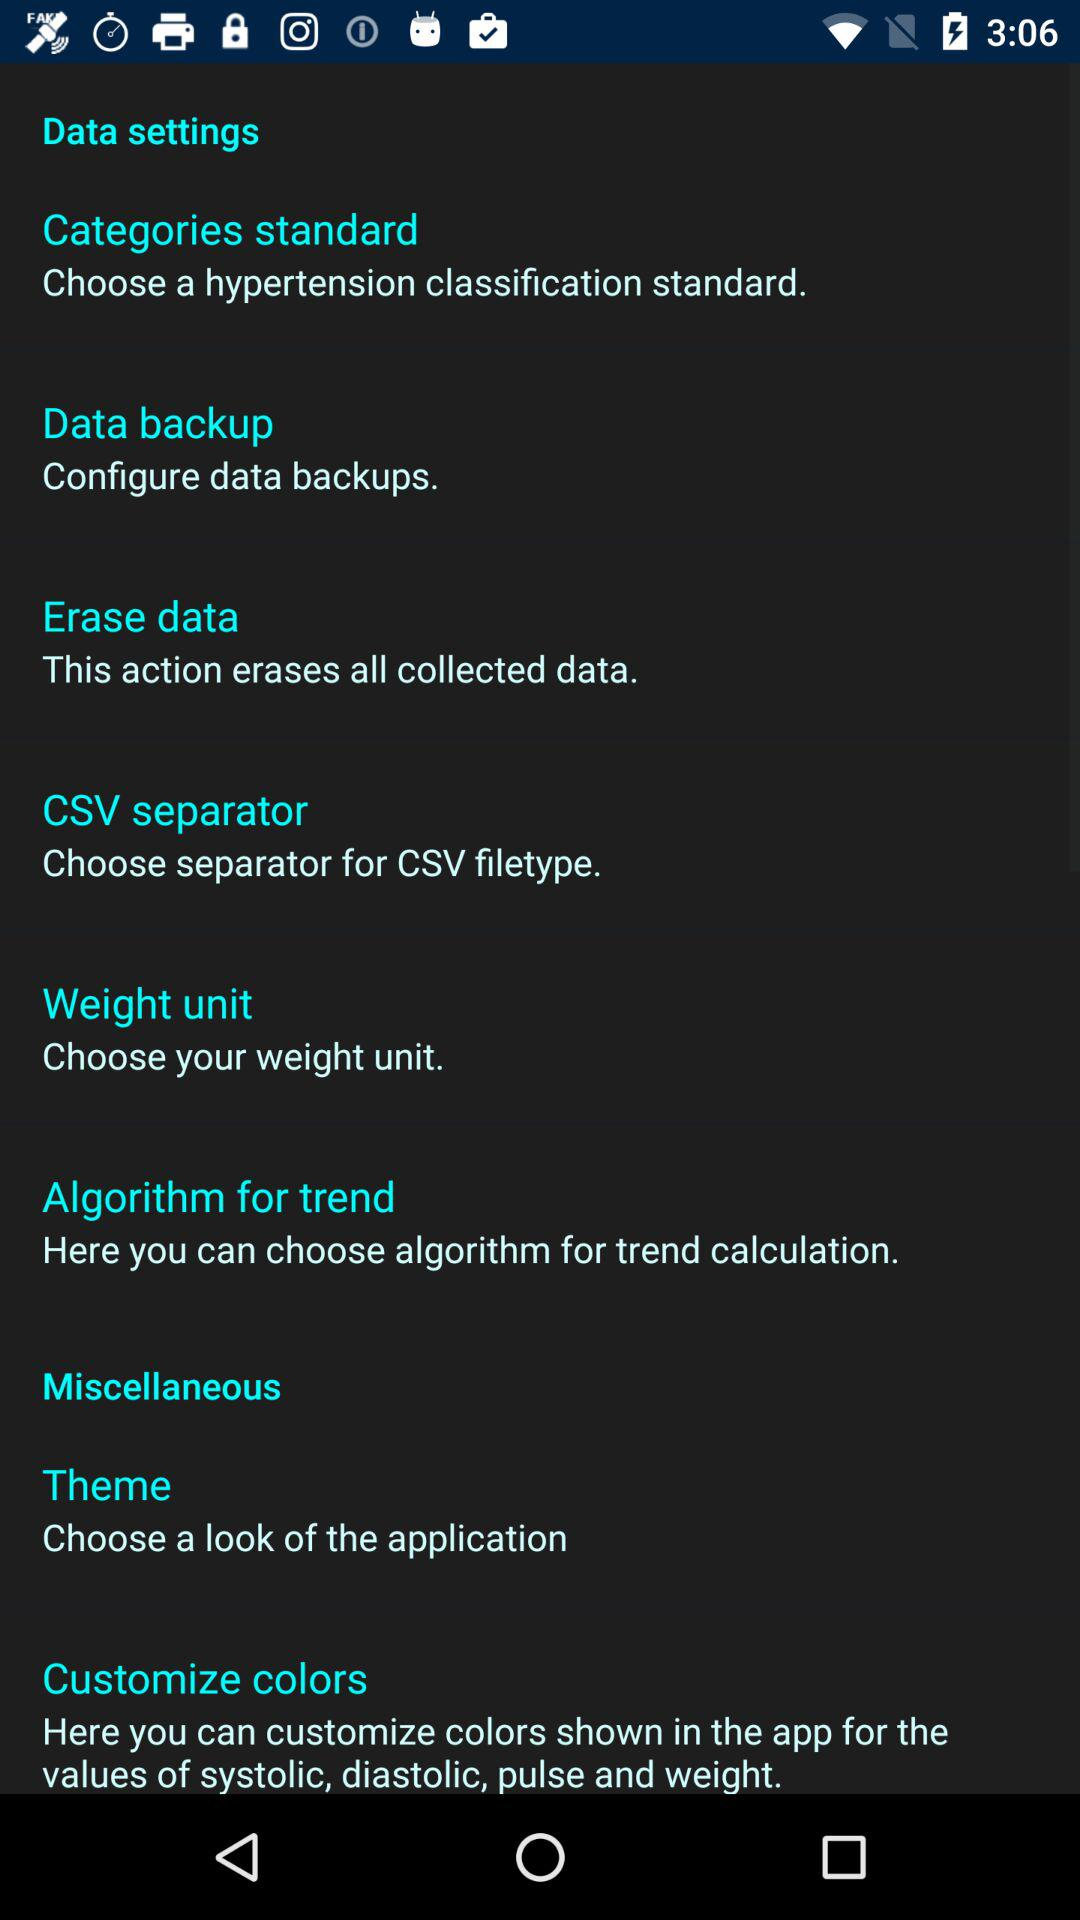How many items are in the 'Miscellaneous' section?
Answer the question using a single word or phrase. 2 